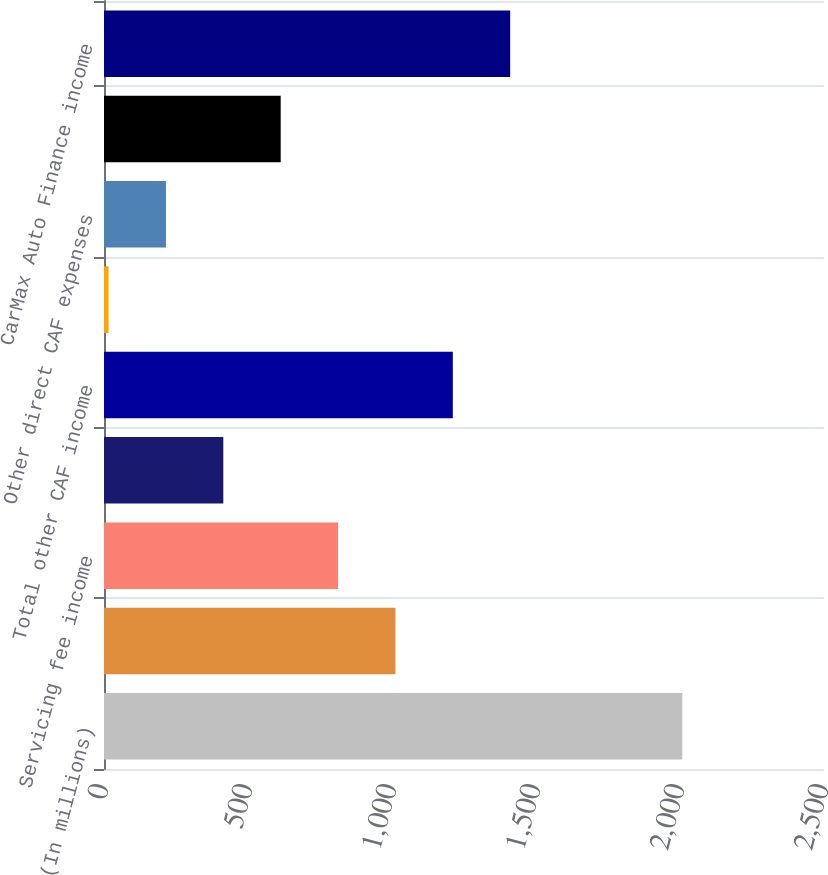Convert chart to OTSL. <chart><loc_0><loc_0><loc_500><loc_500><bar_chart><fcel>(In millions)<fcel>Total gain income<fcel>Servicing fee income<fcel>Interest income<fcel>Total other CAF income<fcel>CAF payroll and fringe benefit<fcel>Other direct CAF expenses<fcel>Total direct CAF expenses<fcel>CarMax Auto Finance income<nl><fcel>2008<fcel>1011.95<fcel>812.74<fcel>414.32<fcel>1211.16<fcel>15.9<fcel>215.11<fcel>613.53<fcel>1410.37<nl></chart> 